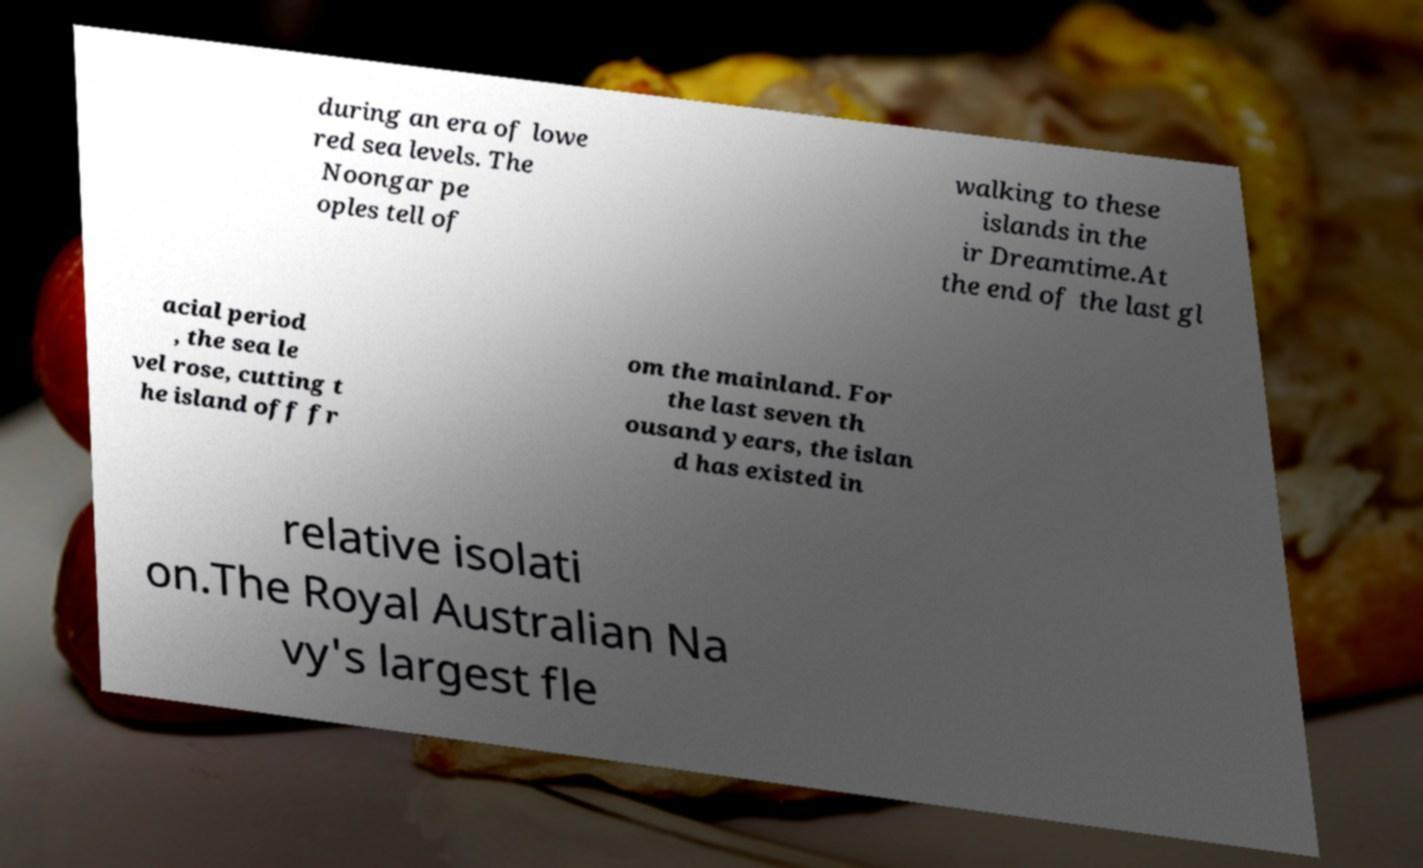Could you assist in decoding the text presented in this image and type it out clearly? during an era of lowe red sea levels. The Noongar pe oples tell of walking to these islands in the ir Dreamtime.At the end of the last gl acial period , the sea le vel rose, cutting t he island off fr om the mainland. For the last seven th ousand years, the islan d has existed in relative isolati on.The Royal Australian Na vy's largest fle 